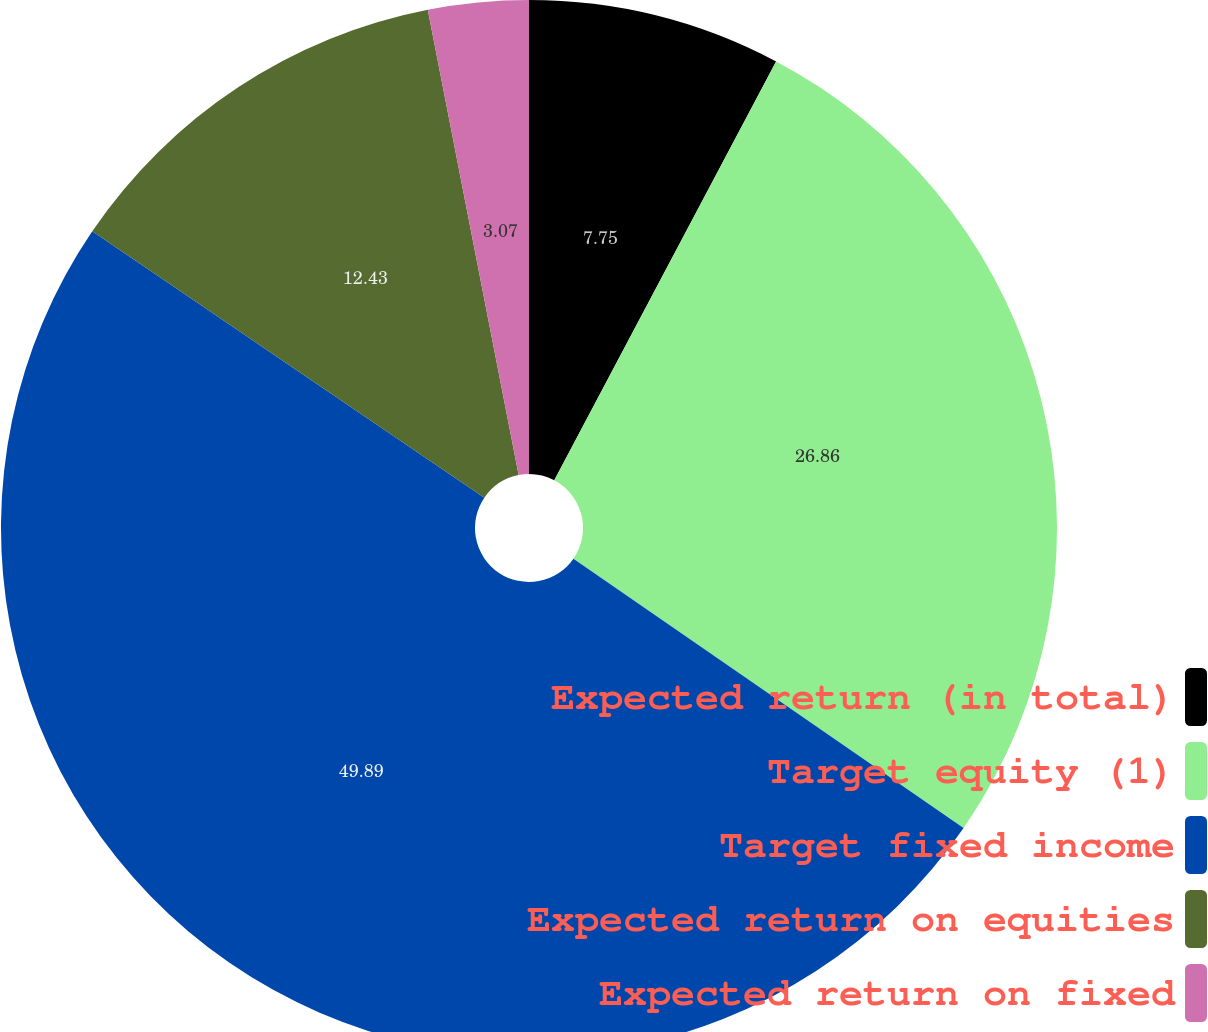Convert chart. <chart><loc_0><loc_0><loc_500><loc_500><pie_chart><fcel>Expected return (in total)<fcel>Target equity (1)<fcel>Target fixed income<fcel>Expected return on equities<fcel>Expected return on fixed<nl><fcel>7.75%<fcel>26.86%<fcel>49.88%<fcel>12.43%<fcel>3.07%<nl></chart> 